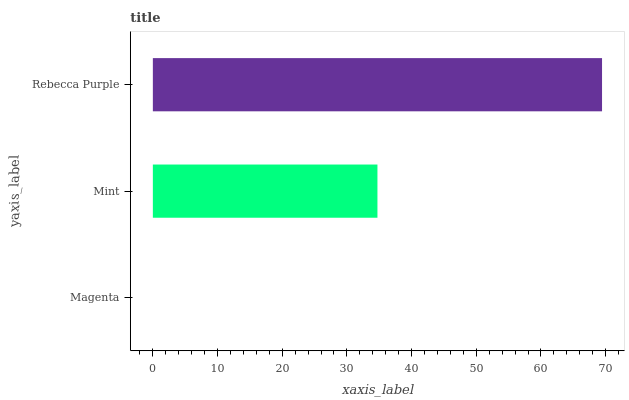Is Magenta the minimum?
Answer yes or no. Yes. Is Rebecca Purple the maximum?
Answer yes or no. Yes. Is Mint the minimum?
Answer yes or no. No. Is Mint the maximum?
Answer yes or no. No. Is Mint greater than Magenta?
Answer yes or no. Yes. Is Magenta less than Mint?
Answer yes or no. Yes. Is Magenta greater than Mint?
Answer yes or no. No. Is Mint less than Magenta?
Answer yes or no. No. Is Mint the high median?
Answer yes or no. Yes. Is Mint the low median?
Answer yes or no. Yes. Is Rebecca Purple the high median?
Answer yes or no. No. Is Magenta the low median?
Answer yes or no. No. 